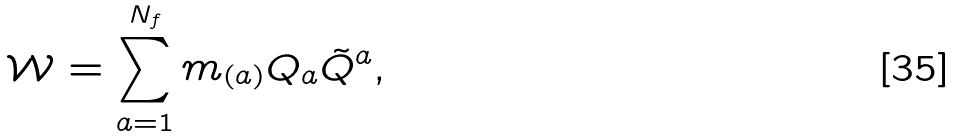<formula> <loc_0><loc_0><loc_500><loc_500>\mathcal { W } = \sum _ { a = 1 } ^ { N _ { f } } m _ { ( a ) } Q _ { a } \tilde { Q } ^ { a } ,</formula> 